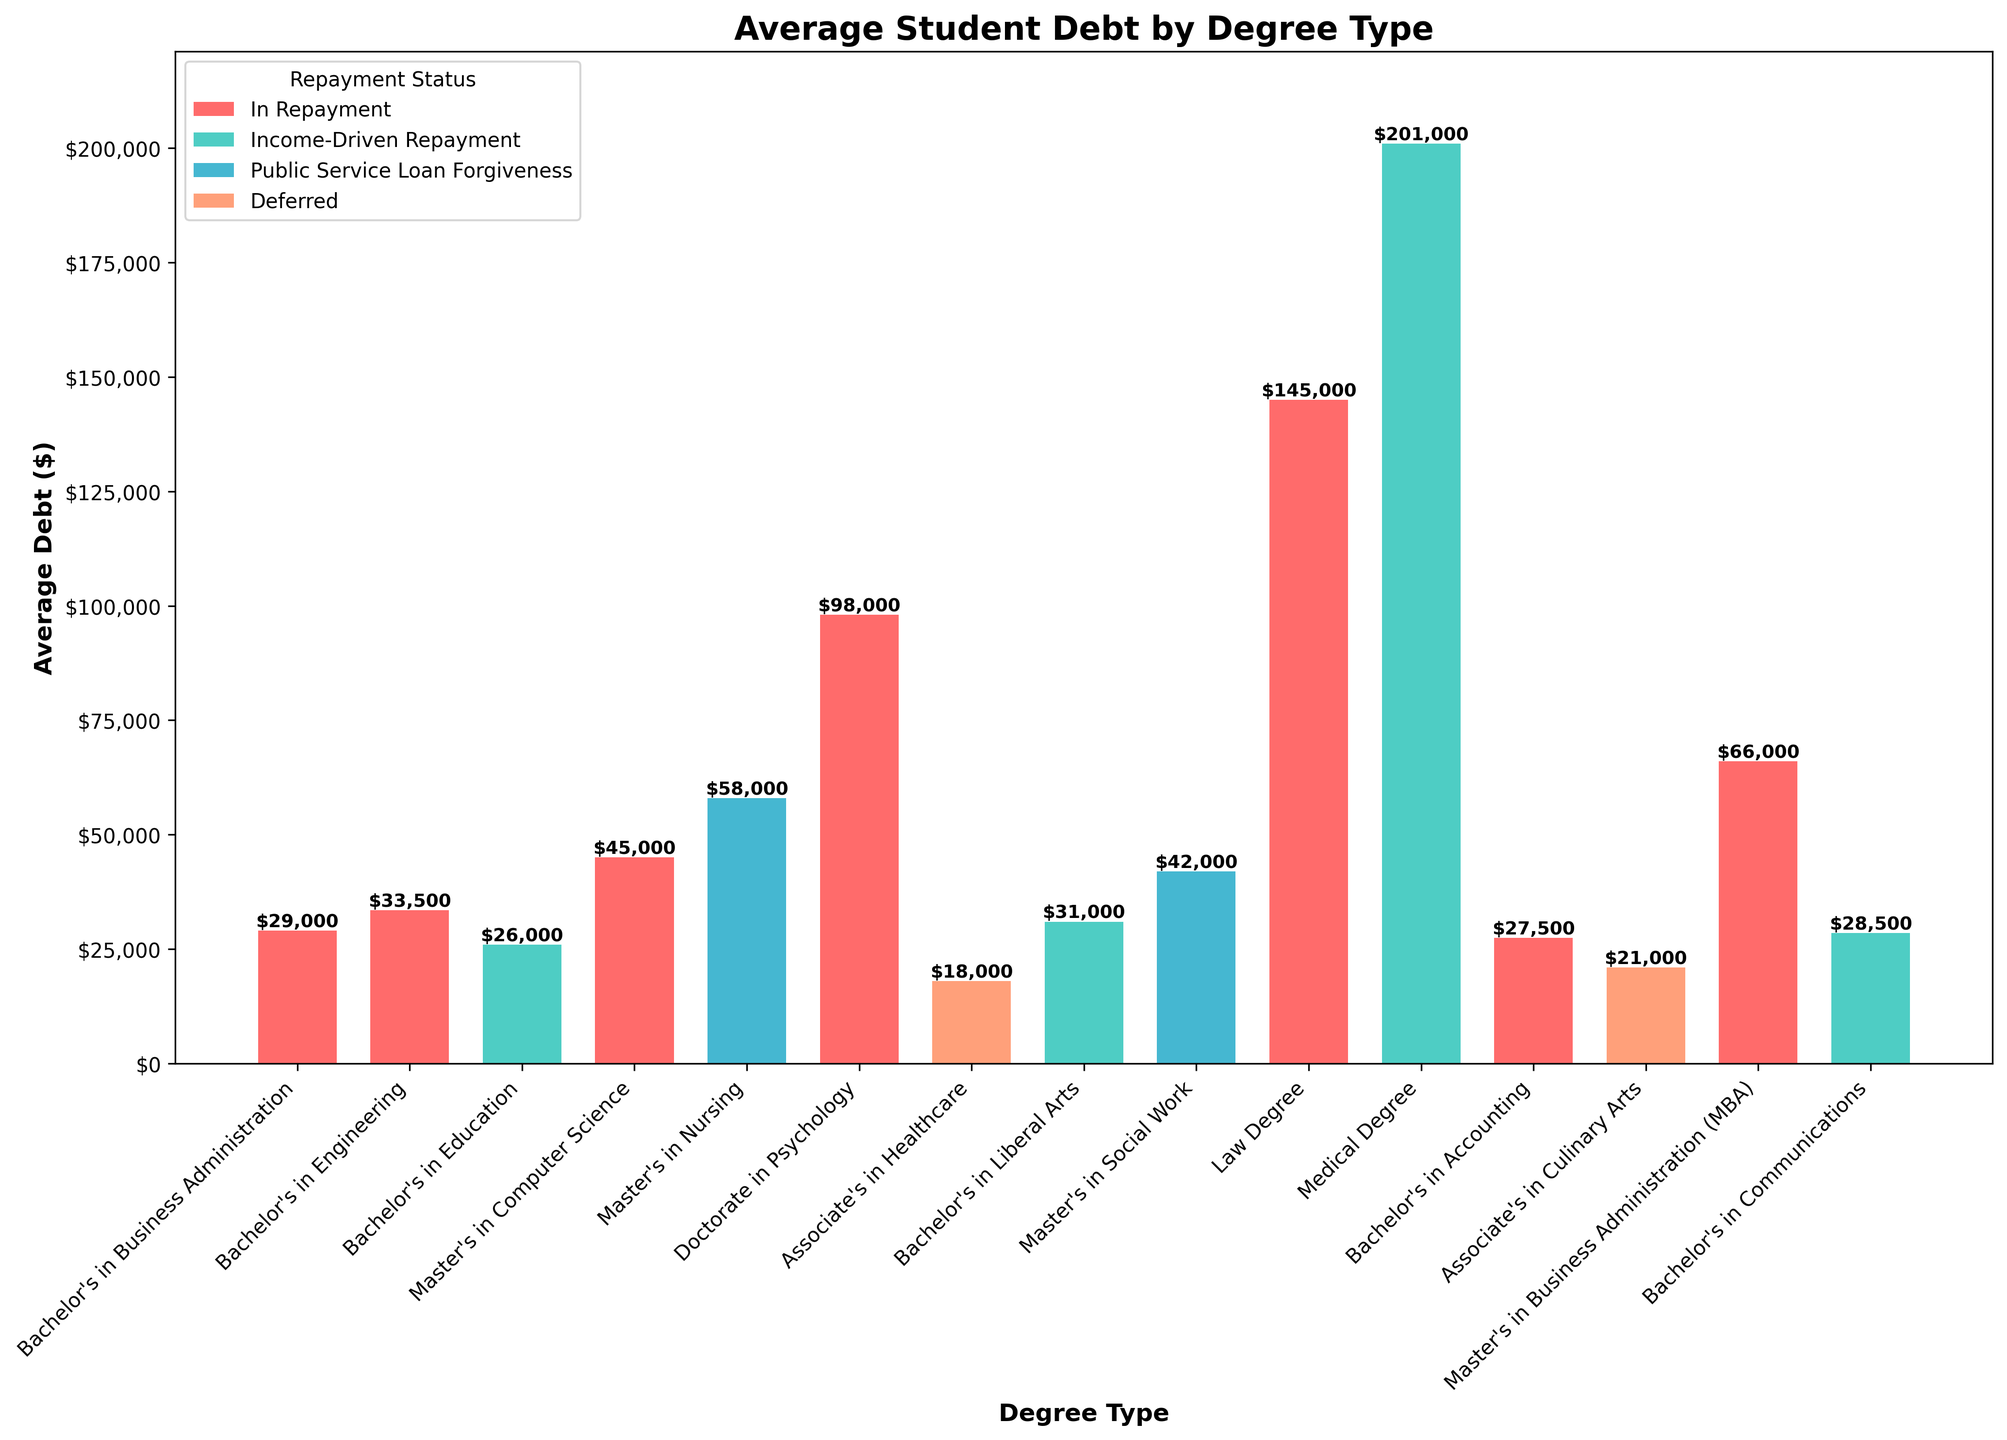What is the degree type with the highest average debt? The tallest bar represents the highest average debt. The degree type for the tallest bar is "Medical Degree," which has an average debt of $201,000.
Answer: Medical Degree Which degree type has the lowest average debt, and what is that debt? The shortest bar represents the lowest average debt. The degree type for the shortest bar is "Associate's in Healthcare," with an average debt of $18,000.
Answer: Associate's in Healthcare, $18,000 What is the total average debt for bachelor's degrees in Business Administration, Engineering, and Education combined? Add the average debts for these degree types: $29,000 (Business Administration) + $33,500 (Engineering) + $26,000 (Education). The total is $88,500.
Answer: $88,500 Which repayment status has the most degree types associated with it? Count the number of bars for each repayment status by examining the colors. "In Repayment" has the most bars, indicating it is the repayment status with the most degree types associated with it.
Answer: In Repayment How much higher is the average debt for a Medical Degree compared to an MBA? Subtract the average debt for the MBA from the Medical Degree: $201,000 (Medical Degree) - $66,000 (MBA) = $135,000.
Answer: $135,000 Which degree types have average debts between $40,000 and $50,000? Identify the bars that fall within the $40,000 to $50,000 range. The degree types are "Master's in Computer Science" ($45,000) and "Master's in Social Work" ($42,000).
Answer: Master's in Computer Science, Master's in Social Work What is the difference in average debt between the Bachelor's in Communications and the Associate's in Culinary Arts? Subtract the average debt for the Associate's in Culinary Arts from the Bachelor's in Communications: $28,500 (Communications) - $21,000 (Culinary Arts) = $7,500.
Answer: $7,500 What is the average debt for degrees with "Income-Driven Repayment" status? Sum the average debts for degrees with "Income-Driven Repayment": $26,000 (Bachelor's in Education) + $31,000 (Bachelor's in Liberal Arts) + $201,000 (Medical Degree) + $28,500 (Bachelor's in Communications) = $286,500. Divide by the number of degrees (4): $286,500 / 4 = $71,625.
Answer: $71,625 